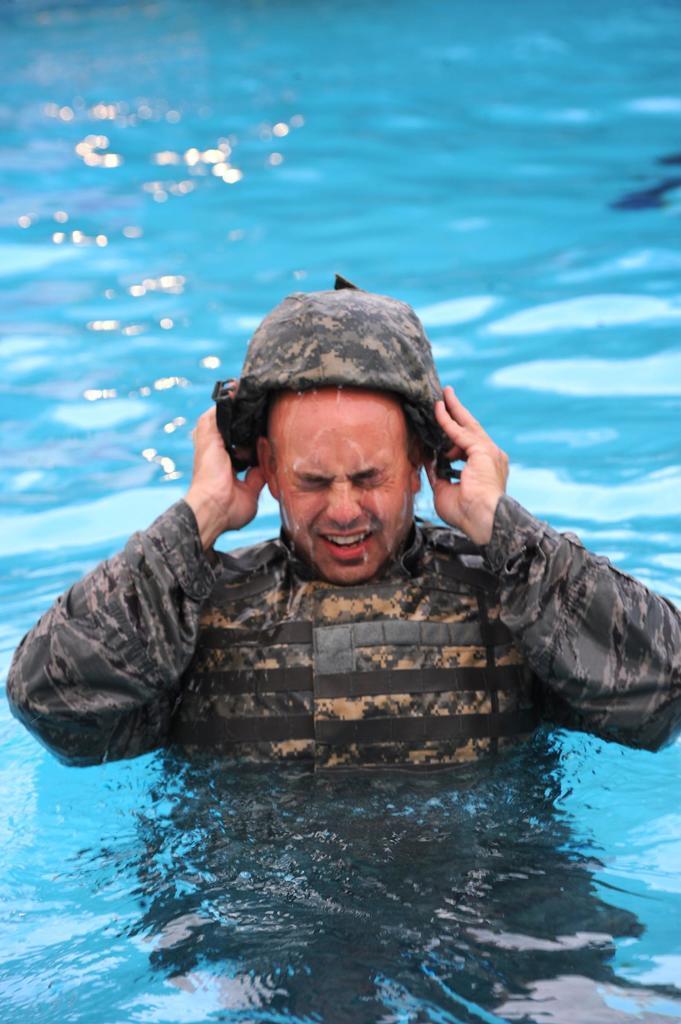Please provide a concise description of this image. In this image I can see the person with the dress and cap. I can see the person is in the swimming pool. 